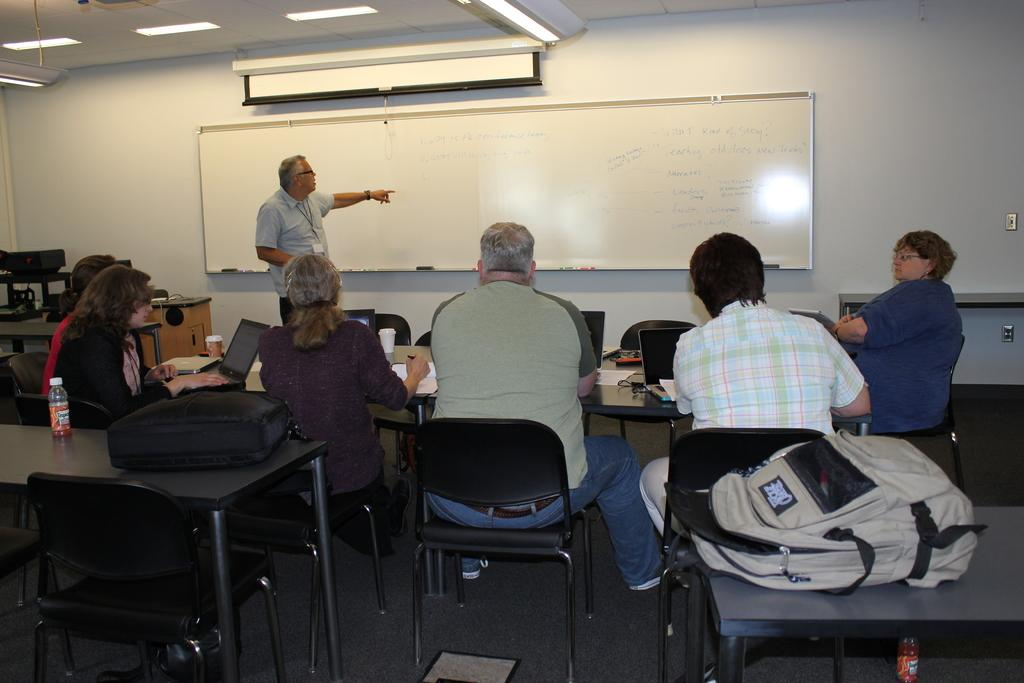How many people are in the room in the image? There are seven persons in the room. What are most of the people doing in the room? Six of them are sitting, while one person is standing. What furniture is present in the room? There is a chair and a table in the room. What items can be seen on the table? There is a bag and a water bottle on the table. What is the purpose of the whiteboard in the room? The whiteboard is likely used for writing or displaying information. What type of comb is being used by the person standing in the image? There is no comb visible in the image; the person standing is not using one. How many books are being adjusted on the table by the sitting persons? There are no books present in the image; the conversation does not mention any books. 